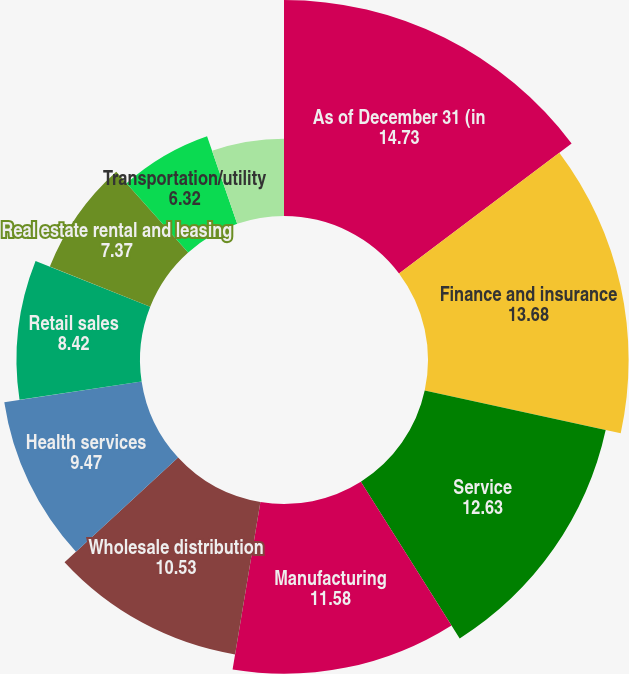Convert chart. <chart><loc_0><loc_0><loc_500><loc_500><pie_chart><fcel>As of December 31 (in<fcel>Finance and insurance<fcel>Service<fcel>Manufacturing<fcel>Wholesale distribution<fcel>Health services<fcel>Retail sales<fcel>Real estate rental and leasing<fcel>Transportation/utility<fcel>Construction<nl><fcel>14.73%<fcel>13.68%<fcel>12.63%<fcel>11.58%<fcel>10.53%<fcel>9.47%<fcel>8.42%<fcel>7.37%<fcel>6.32%<fcel>5.27%<nl></chart> 